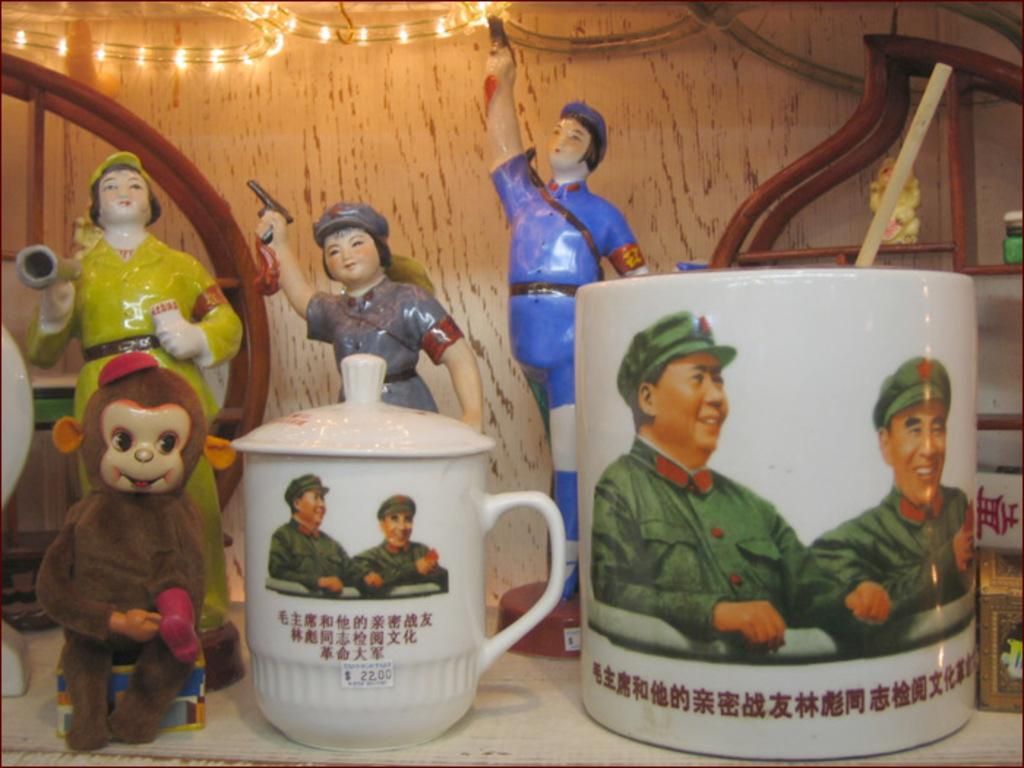What type of dolls are in the image? There are ceramic dolls in the image. How many objects are in the foreground of the image? There are two objects in the foreground of the image. What can be seen on the objects in the foreground? The objects have pictures of two men. What can be seen in the background of the image? There is a light in the background of the image. What type of muscle treatment is being performed on the dolls in the image? There is no muscle treatment being performed on the dolls in the image, as they are ceramic and not capable of receiving such treatment. 